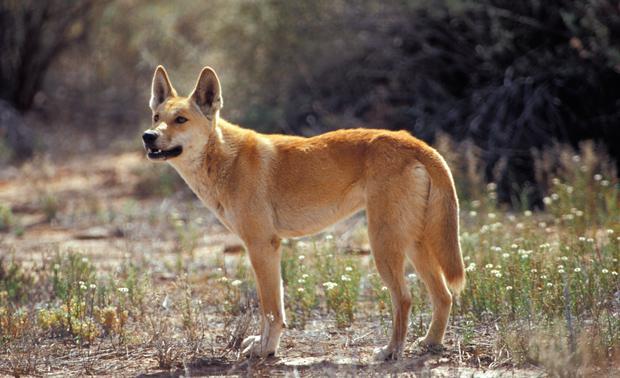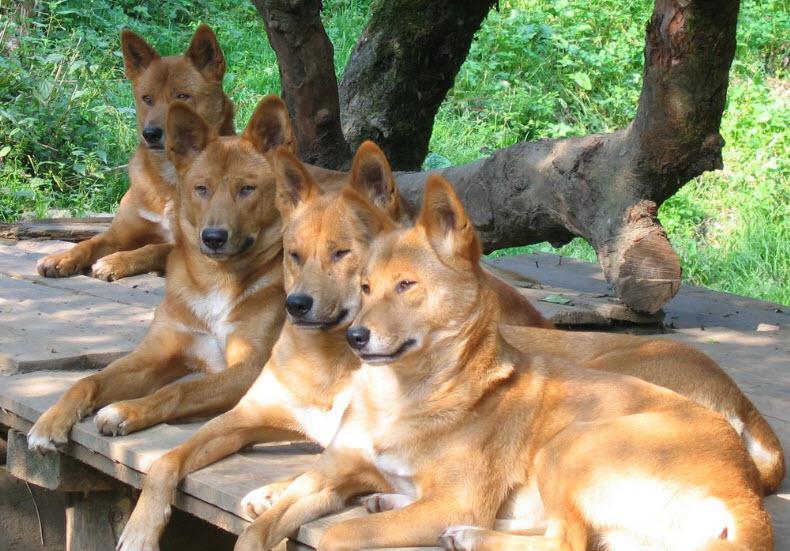The first image is the image on the left, the second image is the image on the right. For the images shown, is this caption "Several animals are standing in the grass in the image on the left." true? Answer yes or no. No. The first image is the image on the left, the second image is the image on the right. For the images shown, is this caption "The right image includes more than twice the number of dogs as the left image." true? Answer yes or no. Yes. 